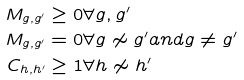<formula> <loc_0><loc_0><loc_500><loc_500>M _ { g , g ^ { \prime } } & \geq 0 \forall g , g ^ { \prime } \\ M _ { g , g ^ { \prime } } & = 0 \forall g \not \sim g ^ { \prime } a n d g \neq g ^ { \prime } \\ C _ { h , h ^ { \prime } } & \geq 1 \forall h \not \sim h ^ { \prime }</formula> 